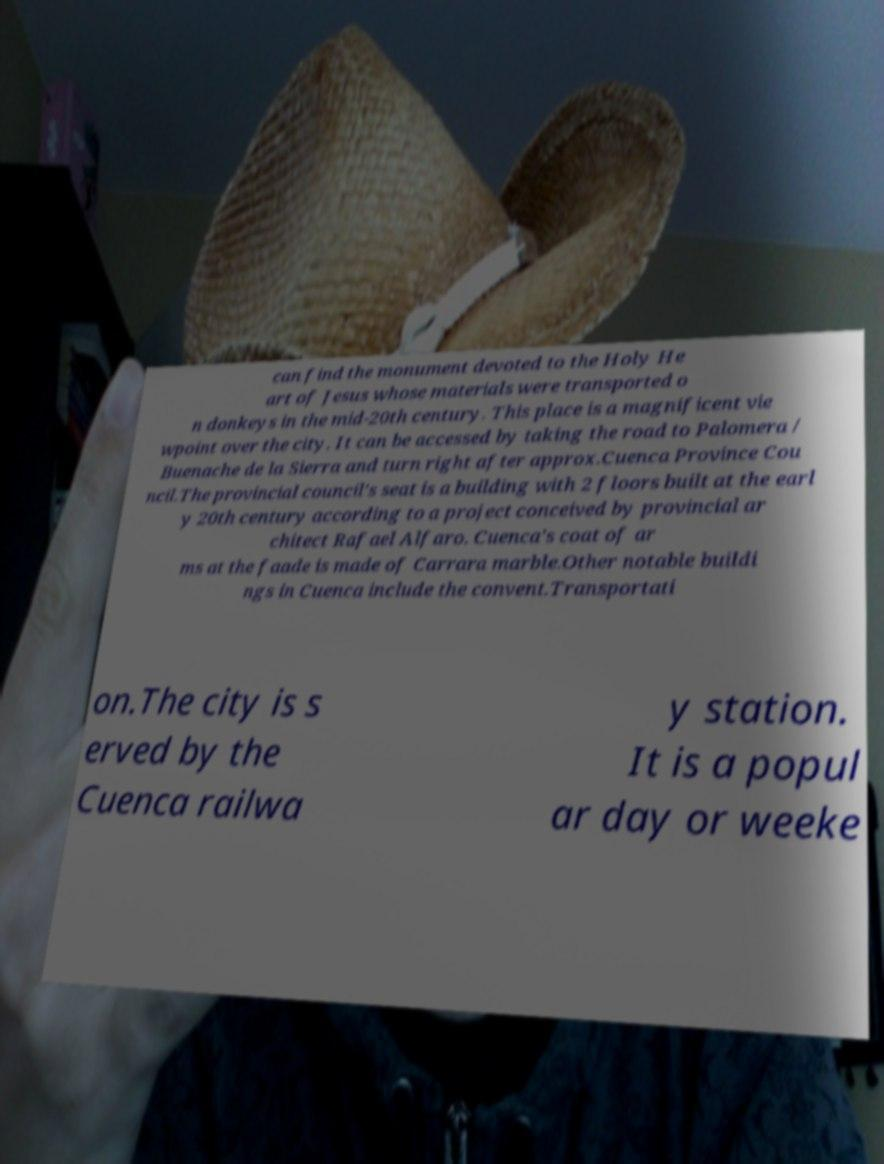Can you read and provide the text displayed in the image?This photo seems to have some interesting text. Can you extract and type it out for me? can find the monument devoted to the Holy He art of Jesus whose materials were transported o n donkeys in the mid-20th century. This place is a magnificent vie wpoint over the city. It can be accessed by taking the road to Palomera / Buenache de la Sierra and turn right after approx.Cuenca Province Cou ncil.The provincial council's seat is a building with 2 floors built at the earl y 20th century according to a project conceived by provincial ar chitect Rafael Alfaro. Cuenca's coat of ar ms at the faade is made of Carrara marble.Other notable buildi ngs in Cuenca include the convent.Transportati on.The city is s erved by the Cuenca railwa y station. It is a popul ar day or weeke 